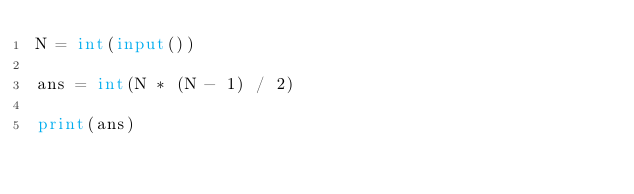<code> <loc_0><loc_0><loc_500><loc_500><_Python_>N = int(input())

ans = int(N * (N - 1) / 2)

print(ans)</code> 